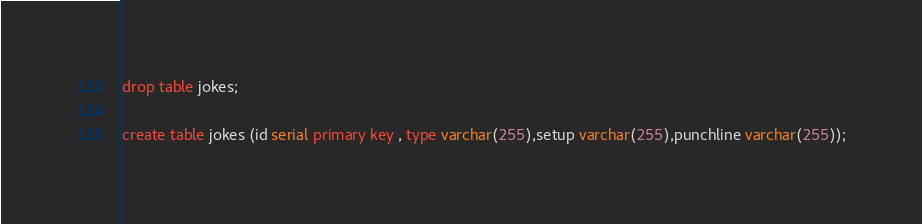Convert code to text. <code><loc_0><loc_0><loc_500><loc_500><_SQL_>drop table jokes;

create table jokes (id serial primary key , type varchar(255),setup varchar(255),punchline varchar(255));</code> 